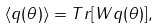<formula> <loc_0><loc_0><loc_500><loc_500>\langle q ( \theta ) \rangle = T r [ W q ( \theta ) ] ,</formula> 